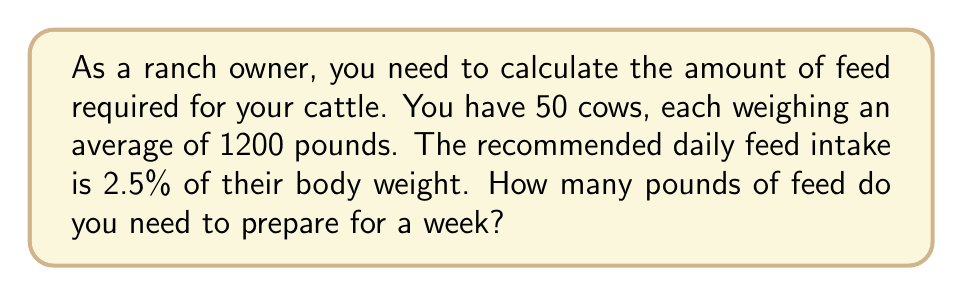Could you help me with this problem? Let's break this problem down into steps:

1. Calculate the daily feed intake for one cow:
   $$\text{Daily feed per cow} = 1200 \text{ lbs} \times 2.5\% = 1200 \text{ lbs} \times 0.025 = 30 \text{ lbs}$$

2. Calculate the daily feed intake for all 50 cows:
   $$\text{Daily feed for all cows} = 30 \text{ lbs} \times 50 = 1500 \text{ lbs}$$

3. Calculate the feed needed for a week (7 days):
   $$\text{Weekly feed} = 1500 \text{ lbs} \times 7 \text{ days} = 10,500 \text{ lbs}$$

Therefore, you need to prepare 10,500 pounds of feed for your cattle for one week.
Answer: $10,500 \text{ lbs}$ 